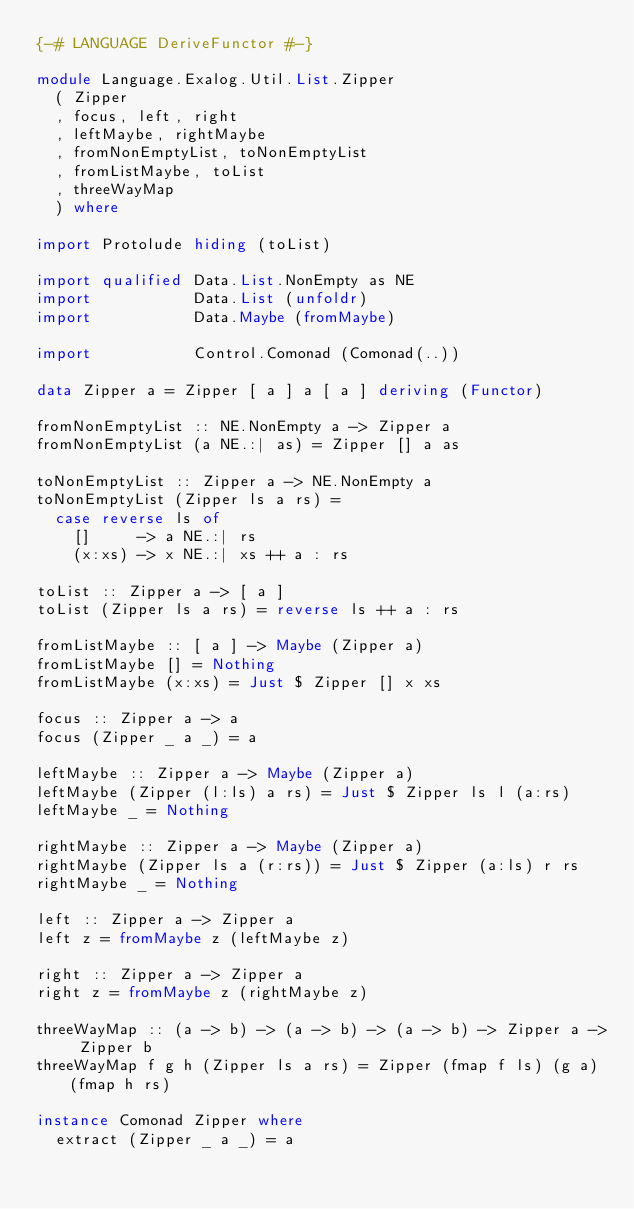<code> <loc_0><loc_0><loc_500><loc_500><_Haskell_>{-# LANGUAGE DeriveFunctor #-}

module Language.Exalog.Util.List.Zipper
  ( Zipper
  , focus, left, right
  , leftMaybe, rightMaybe
  , fromNonEmptyList, toNonEmptyList
  , fromListMaybe, toList
  , threeWayMap
  ) where

import Protolude hiding (toList)

import qualified Data.List.NonEmpty as NE
import           Data.List (unfoldr)
import           Data.Maybe (fromMaybe)

import           Control.Comonad (Comonad(..))

data Zipper a = Zipper [ a ] a [ a ] deriving (Functor)

fromNonEmptyList :: NE.NonEmpty a -> Zipper a
fromNonEmptyList (a NE.:| as) = Zipper [] a as

toNonEmptyList :: Zipper a -> NE.NonEmpty a
toNonEmptyList (Zipper ls a rs) =
  case reverse ls of
    []     -> a NE.:| rs
    (x:xs) -> x NE.:| xs ++ a : rs

toList :: Zipper a -> [ a ]
toList (Zipper ls a rs) = reverse ls ++ a : rs

fromListMaybe :: [ a ] -> Maybe (Zipper a)
fromListMaybe [] = Nothing
fromListMaybe (x:xs) = Just $ Zipper [] x xs

focus :: Zipper a -> a
focus (Zipper _ a _) = a

leftMaybe :: Zipper a -> Maybe (Zipper a)
leftMaybe (Zipper (l:ls) a rs) = Just $ Zipper ls l (a:rs)
leftMaybe _ = Nothing

rightMaybe :: Zipper a -> Maybe (Zipper a)
rightMaybe (Zipper ls a (r:rs)) = Just $ Zipper (a:ls) r rs
rightMaybe _ = Nothing

left :: Zipper a -> Zipper a
left z = fromMaybe z (leftMaybe z)

right :: Zipper a -> Zipper a
right z = fromMaybe z (rightMaybe z)

threeWayMap :: (a -> b) -> (a -> b) -> (a -> b) -> Zipper a -> Zipper b
threeWayMap f g h (Zipper ls a rs) = Zipper (fmap f ls) (g a) (fmap h rs)

instance Comonad Zipper where
  extract (Zipper _ a _) = a</code> 